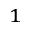<formula> <loc_0><loc_0><loc_500><loc_500>_ { 1 }</formula> 